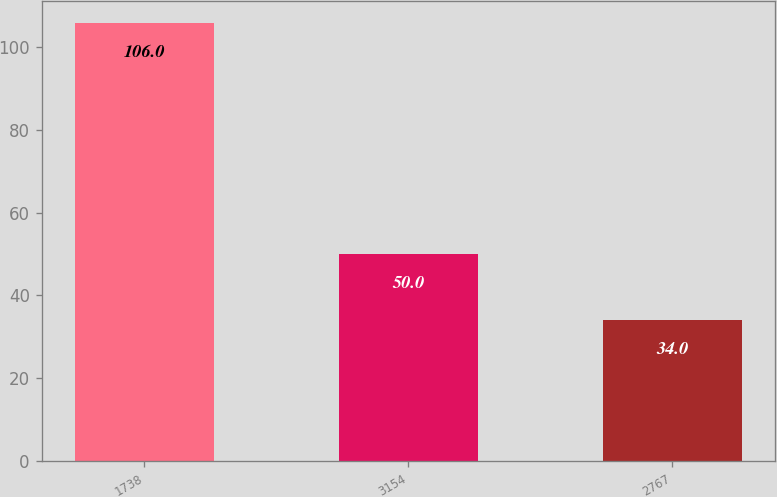Convert chart to OTSL. <chart><loc_0><loc_0><loc_500><loc_500><bar_chart><fcel>1738<fcel>3154<fcel>2767<nl><fcel>106<fcel>50<fcel>34<nl></chart> 